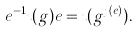Convert formula to latex. <formula><loc_0><loc_0><loc_500><loc_500>e ^ { - 1 } \imath ( g ) e = \imath ( g ^ { \jmath ( e ) } ) .</formula> 